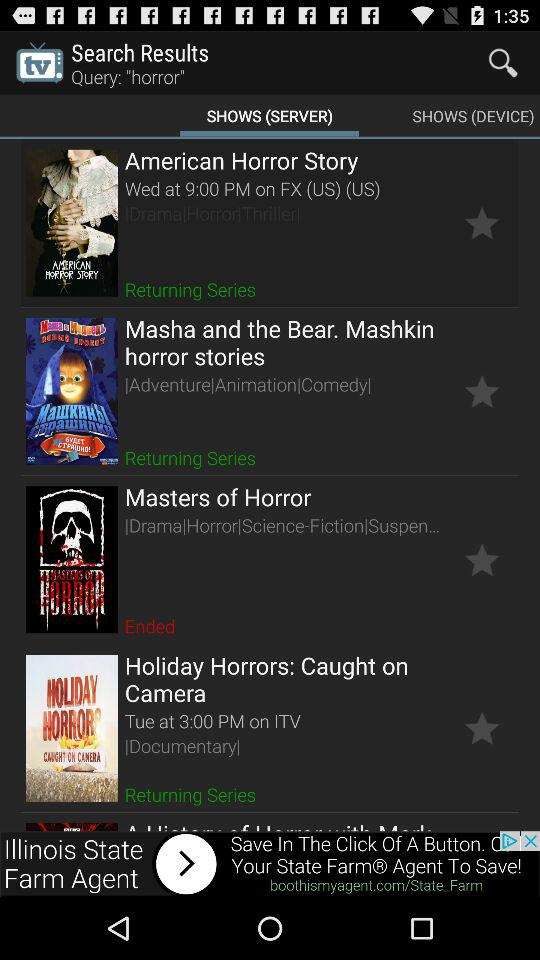What type of show is "Holiday Horrors: Caught on Camera"? The type of show is documentary. 